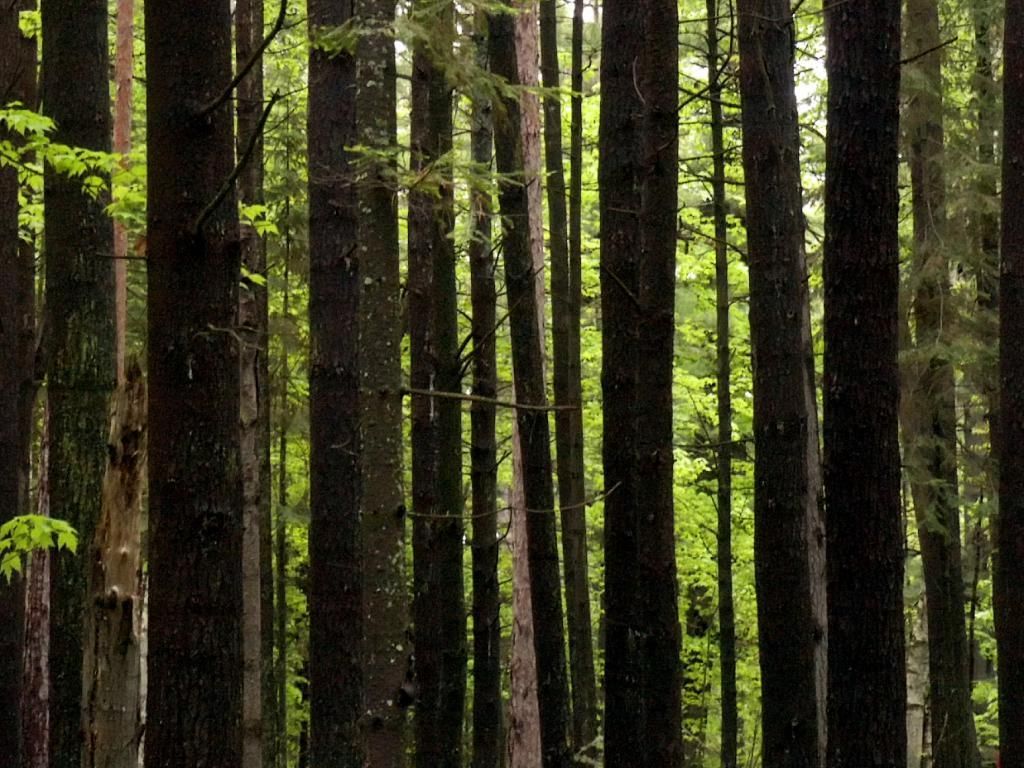What type of natural objects can be seen in the image? There are tree trunks and trees in the image. Can you describe the main elements of the image? The image primarily features tree trunks and trees. What type of pollution can be seen in the image? There is no pollution visible in the image; it primarily features tree trunks and trees. What type of quilt is draped over the tree trunks in the image? There is no quilt present in the image; it primarily features tree trunks and trees. 